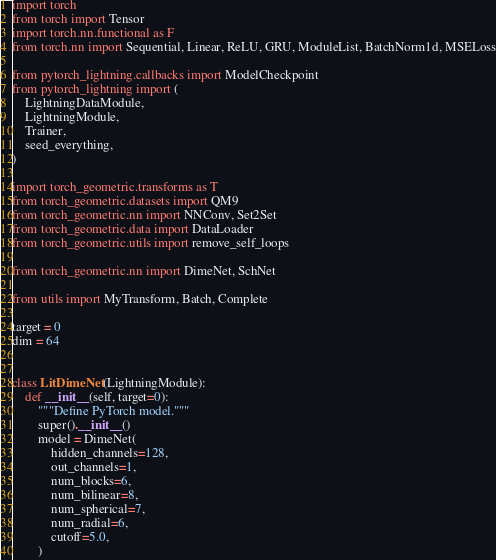<code> <loc_0><loc_0><loc_500><loc_500><_Python_>
import torch
from torch import Tensor
import torch.nn.functional as F
from torch.nn import Sequential, Linear, ReLU, GRU, ModuleList, BatchNorm1d, MSELoss

from pytorch_lightning.callbacks import ModelCheckpoint
from pytorch_lightning import (
    LightningDataModule,
    LightningModule,
    Trainer,
    seed_everything,
)

import torch_geometric.transforms as T
from torch_geometric.datasets import QM9
from torch_geometric.nn import NNConv, Set2Set
from torch_geometric.data import DataLoader
from torch_geometric.utils import remove_self_loops

from torch_geometric.nn import DimeNet, SchNet

from utils import MyTransform, Batch, Complete

target = 0
dim = 64


class LitDimeNet(LightningModule):
    def __init__(self, target=0):
        """Define PyTorch model."""
        super().__init__()
        model = DimeNet(
            hidden_channels=128,
            out_channels=1,
            num_blocks=6,
            num_bilinear=8,
            num_spherical=7,
            num_radial=6,
            cutoff=5.0,
        )</code> 